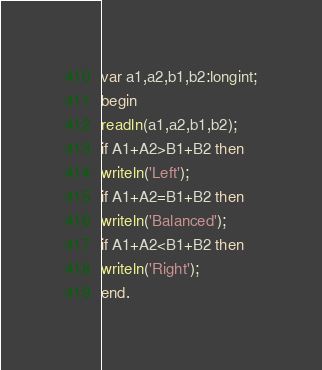Convert code to text. <code><loc_0><loc_0><loc_500><loc_500><_Pascal_>var a1,a2,b1,b2:longint;
begin
readln(a1,a2,b1,b2);
if A1+A2>B1+B2 then
writeln('Left');
if A1+A2=B1+B2 then
writeln('Balanced');
if A1+A2<B1+B2 then
writeln('Right');
end.</code> 